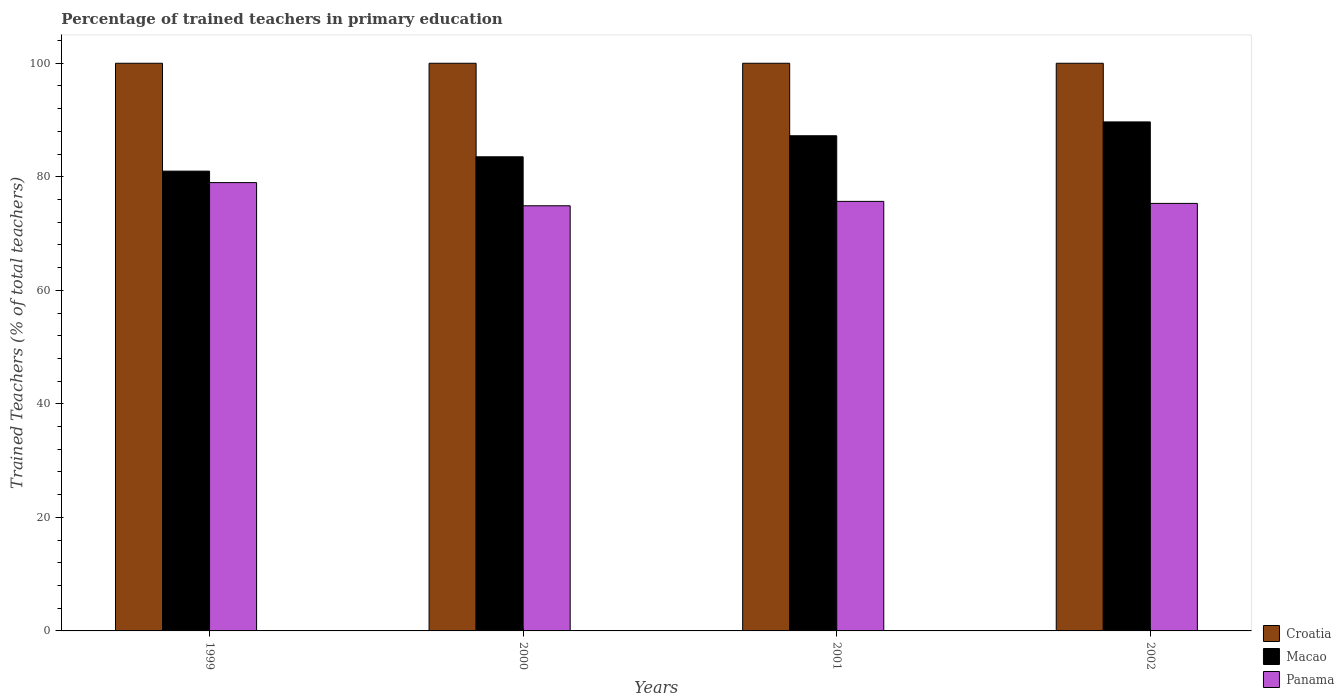How many different coloured bars are there?
Your response must be concise. 3. How many groups of bars are there?
Make the answer very short. 4. How many bars are there on the 1st tick from the left?
Offer a very short reply. 3. How many bars are there on the 4th tick from the right?
Offer a very short reply. 3. What is the label of the 1st group of bars from the left?
Your response must be concise. 1999. What is the percentage of trained teachers in Panama in 2001?
Provide a succinct answer. 75.67. Across all years, what is the maximum percentage of trained teachers in Croatia?
Your response must be concise. 100. Across all years, what is the minimum percentage of trained teachers in Croatia?
Offer a very short reply. 100. In which year was the percentage of trained teachers in Panama maximum?
Give a very brief answer. 1999. In which year was the percentage of trained teachers in Macao minimum?
Offer a terse response. 1999. What is the total percentage of trained teachers in Macao in the graph?
Your answer should be compact. 341.41. What is the difference between the percentage of trained teachers in Panama in 1999 and that in 2000?
Offer a very short reply. 4.08. What is the difference between the percentage of trained teachers in Croatia in 2001 and the percentage of trained teachers in Macao in 2002?
Make the answer very short. 10.33. What is the average percentage of trained teachers in Macao per year?
Your response must be concise. 85.35. In the year 2002, what is the difference between the percentage of trained teachers in Panama and percentage of trained teachers in Macao?
Offer a very short reply. -14.35. Is the percentage of trained teachers in Panama in 1999 less than that in 2001?
Offer a terse response. No. Is the difference between the percentage of trained teachers in Panama in 2001 and 2002 greater than the difference between the percentage of trained teachers in Macao in 2001 and 2002?
Provide a short and direct response. Yes. What is the difference between the highest and the second highest percentage of trained teachers in Macao?
Offer a terse response. 2.44. In how many years, is the percentage of trained teachers in Macao greater than the average percentage of trained teachers in Macao taken over all years?
Offer a terse response. 2. What does the 2nd bar from the left in 2000 represents?
Offer a very short reply. Macao. What does the 1st bar from the right in 2002 represents?
Make the answer very short. Panama. Is it the case that in every year, the sum of the percentage of trained teachers in Croatia and percentage of trained teachers in Panama is greater than the percentage of trained teachers in Macao?
Keep it short and to the point. Yes. How many bars are there?
Keep it short and to the point. 12. How many years are there in the graph?
Offer a terse response. 4. Does the graph contain any zero values?
Offer a very short reply. No. Where does the legend appear in the graph?
Your answer should be compact. Bottom right. What is the title of the graph?
Your answer should be very brief. Percentage of trained teachers in primary education. Does "Northern Mariana Islands" appear as one of the legend labels in the graph?
Provide a short and direct response. No. What is the label or title of the X-axis?
Offer a terse response. Years. What is the label or title of the Y-axis?
Provide a short and direct response. Trained Teachers (% of total teachers). What is the Trained Teachers (% of total teachers) of Croatia in 1999?
Give a very brief answer. 100. What is the Trained Teachers (% of total teachers) in Macao in 1999?
Provide a succinct answer. 81. What is the Trained Teachers (% of total teachers) in Panama in 1999?
Make the answer very short. 78.98. What is the Trained Teachers (% of total teachers) in Macao in 2000?
Make the answer very short. 83.52. What is the Trained Teachers (% of total teachers) in Panama in 2000?
Offer a terse response. 74.89. What is the Trained Teachers (% of total teachers) of Macao in 2001?
Offer a terse response. 87.23. What is the Trained Teachers (% of total teachers) in Panama in 2001?
Your answer should be very brief. 75.67. What is the Trained Teachers (% of total teachers) of Croatia in 2002?
Make the answer very short. 100. What is the Trained Teachers (% of total teachers) in Macao in 2002?
Your answer should be very brief. 89.67. What is the Trained Teachers (% of total teachers) of Panama in 2002?
Your answer should be very brief. 75.31. Across all years, what is the maximum Trained Teachers (% of total teachers) in Macao?
Your answer should be compact. 89.67. Across all years, what is the maximum Trained Teachers (% of total teachers) of Panama?
Give a very brief answer. 78.98. Across all years, what is the minimum Trained Teachers (% of total teachers) of Macao?
Keep it short and to the point. 81. Across all years, what is the minimum Trained Teachers (% of total teachers) of Panama?
Provide a succinct answer. 74.89. What is the total Trained Teachers (% of total teachers) in Croatia in the graph?
Keep it short and to the point. 400. What is the total Trained Teachers (% of total teachers) of Macao in the graph?
Make the answer very short. 341.41. What is the total Trained Teachers (% of total teachers) of Panama in the graph?
Make the answer very short. 304.85. What is the difference between the Trained Teachers (% of total teachers) in Croatia in 1999 and that in 2000?
Provide a short and direct response. 0. What is the difference between the Trained Teachers (% of total teachers) in Macao in 1999 and that in 2000?
Give a very brief answer. -2.53. What is the difference between the Trained Teachers (% of total teachers) of Panama in 1999 and that in 2000?
Make the answer very short. 4.08. What is the difference between the Trained Teachers (% of total teachers) in Croatia in 1999 and that in 2001?
Offer a terse response. 0. What is the difference between the Trained Teachers (% of total teachers) in Macao in 1999 and that in 2001?
Make the answer very short. -6.23. What is the difference between the Trained Teachers (% of total teachers) of Panama in 1999 and that in 2001?
Give a very brief answer. 3.31. What is the difference between the Trained Teachers (% of total teachers) in Macao in 1999 and that in 2002?
Your answer should be compact. -8.67. What is the difference between the Trained Teachers (% of total teachers) in Panama in 1999 and that in 2002?
Offer a terse response. 3.66. What is the difference between the Trained Teachers (% of total teachers) in Croatia in 2000 and that in 2001?
Your answer should be very brief. 0. What is the difference between the Trained Teachers (% of total teachers) of Macao in 2000 and that in 2001?
Make the answer very short. -3.71. What is the difference between the Trained Teachers (% of total teachers) in Panama in 2000 and that in 2001?
Ensure brevity in your answer.  -0.77. What is the difference between the Trained Teachers (% of total teachers) of Croatia in 2000 and that in 2002?
Offer a very short reply. 0. What is the difference between the Trained Teachers (% of total teachers) in Macao in 2000 and that in 2002?
Keep it short and to the point. -6.14. What is the difference between the Trained Teachers (% of total teachers) of Panama in 2000 and that in 2002?
Your answer should be compact. -0.42. What is the difference between the Trained Teachers (% of total teachers) in Macao in 2001 and that in 2002?
Give a very brief answer. -2.44. What is the difference between the Trained Teachers (% of total teachers) in Panama in 2001 and that in 2002?
Offer a terse response. 0.36. What is the difference between the Trained Teachers (% of total teachers) of Croatia in 1999 and the Trained Teachers (% of total teachers) of Macao in 2000?
Give a very brief answer. 16.48. What is the difference between the Trained Teachers (% of total teachers) in Croatia in 1999 and the Trained Teachers (% of total teachers) in Panama in 2000?
Provide a short and direct response. 25.11. What is the difference between the Trained Teachers (% of total teachers) of Macao in 1999 and the Trained Teachers (% of total teachers) of Panama in 2000?
Provide a succinct answer. 6.1. What is the difference between the Trained Teachers (% of total teachers) of Croatia in 1999 and the Trained Teachers (% of total teachers) of Macao in 2001?
Keep it short and to the point. 12.77. What is the difference between the Trained Teachers (% of total teachers) of Croatia in 1999 and the Trained Teachers (% of total teachers) of Panama in 2001?
Your answer should be very brief. 24.33. What is the difference between the Trained Teachers (% of total teachers) in Macao in 1999 and the Trained Teachers (% of total teachers) in Panama in 2001?
Ensure brevity in your answer.  5.33. What is the difference between the Trained Teachers (% of total teachers) of Croatia in 1999 and the Trained Teachers (% of total teachers) of Macao in 2002?
Your answer should be compact. 10.33. What is the difference between the Trained Teachers (% of total teachers) in Croatia in 1999 and the Trained Teachers (% of total teachers) in Panama in 2002?
Ensure brevity in your answer.  24.69. What is the difference between the Trained Teachers (% of total teachers) of Macao in 1999 and the Trained Teachers (% of total teachers) of Panama in 2002?
Provide a succinct answer. 5.68. What is the difference between the Trained Teachers (% of total teachers) in Croatia in 2000 and the Trained Teachers (% of total teachers) in Macao in 2001?
Make the answer very short. 12.77. What is the difference between the Trained Teachers (% of total teachers) of Croatia in 2000 and the Trained Teachers (% of total teachers) of Panama in 2001?
Ensure brevity in your answer.  24.33. What is the difference between the Trained Teachers (% of total teachers) in Macao in 2000 and the Trained Teachers (% of total teachers) in Panama in 2001?
Your response must be concise. 7.86. What is the difference between the Trained Teachers (% of total teachers) of Croatia in 2000 and the Trained Teachers (% of total teachers) of Macao in 2002?
Make the answer very short. 10.33. What is the difference between the Trained Teachers (% of total teachers) of Croatia in 2000 and the Trained Teachers (% of total teachers) of Panama in 2002?
Your response must be concise. 24.69. What is the difference between the Trained Teachers (% of total teachers) of Macao in 2000 and the Trained Teachers (% of total teachers) of Panama in 2002?
Keep it short and to the point. 8.21. What is the difference between the Trained Teachers (% of total teachers) of Croatia in 2001 and the Trained Teachers (% of total teachers) of Macao in 2002?
Your answer should be compact. 10.33. What is the difference between the Trained Teachers (% of total teachers) in Croatia in 2001 and the Trained Teachers (% of total teachers) in Panama in 2002?
Provide a succinct answer. 24.69. What is the difference between the Trained Teachers (% of total teachers) of Macao in 2001 and the Trained Teachers (% of total teachers) of Panama in 2002?
Offer a terse response. 11.92. What is the average Trained Teachers (% of total teachers) of Croatia per year?
Ensure brevity in your answer.  100. What is the average Trained Teachers (% of total teachers) in Macao per year?
Give a very brief answer. 85.35. What is the average Trained Teachers (% of total teachers) in Panama per year?
Make the answer very short. 76.21. In the year 1999, what is the difference between the Trained Teachers (% of total teachers) in Croatia and Trained Teachers (% of total teachers) in Macao?
Offer a very short reply. 19. In the year 1999, what is the difference between the Trained Teachers (% of total teachers) of Croatia and Trained Teachers (% of total teachers) of Panama?
Your response must be concise. 21.02. In the year 1999, what is the difference between the Trained Teachers (% of total teachers) of Macao and Trained Teachers (% of total teachers) of Panama?
Offer a terse response. 2.02. In the year 2000, what is the difference between the Trained Teachers (% of total teachers) in Croatia and Trained Teachers (% of total teachers) in Macao?
Give a very brief answer. 16.48. In the year 2000, what is the difference between the Trained Teachers (% of total teachers) in Croatia and Trained Teachers (% of total teachers) in Panama?
Your answer should be compact. 25.11. In the year 2000, what is the difference between the Trained Teachers (% of total teachers) in Macao and Trained Teachers (% of total teachers) in Panama?
Make the answer very short. 8.63. In the year 2001, what is the difference between the Trained Teachers (% of total teachers) in Croatia and Trained Teachers (% of total teachers) in Macao?
Your answer should be very brief. 12.77. In the year 2001, what is the difference between the Trained Teachers (% of total teachers) of Croatia and Trained Teachers (% of total teachers) of Panama?
Ensure brevity in your answer.  24.33. In the year 2001, what is the difference between the Trained Teachers (% of total teachers) of Macao and Trained Teachers (% of total teachers) of Panama?
Keep it short and to the point. 11.56. In the year 2002, what is the difference between the Trained Teachers (% of total teachers) of Croatia and Trained Teachers (% of total teachers) of Macao?
Your answer should be compact. 10.33. In the year 2002, what is the difference between the Trained Teachers (% of total teachers) of Croatia and Trained Teachers (% of total teachers) of Panama?
Provide a short and direct response. 24.69. In the year 2002, what is the difference between the Trained Teachers (% of total teachers) of Macao and Trained Teachers (% of total teachers) of Panama?
Ensure brevity in your answer.  14.35. What is the ratio of the Trained Teachers (% of total teachers) of Croatia in 1999 to that in 2000?
Offer a very short reply. 1. What is the ratio of the Trained Teachers (% of total teachers) of Macao in 1999 to that in 2000?
Your response must be concise. 0.97. What is the ratio of the Trained Teachers (% of total teachers) of Panama in 1999 to that in 2000?
Ensure brevity in your answer.  1.05. What is the ratio of the Trained Teachers (% of total teachers) of Croatia in 1999 to that in 2001?
Make the answer very short. 1. What is the ratio of the Trained Teachers (% of total teachers) of Panama in 1999 to that in 2001?
Offer a very short reply. 1.04. What is the ratio of the Trained Teachers (% of total teachers) in Croatia in 1999 to that in 2002?
Make the answer very short. 1. What is the ratio of the Trained Teachers (% of total teachers) in Macao in 1999 to that in 2002?
Keep it short and to the point. 0.9. What is the ratio of the Trained Teachers (% of total teachers) of Panama in 1999 to that in 2002?
Make the answer very short. 1.05. What is the ratio of the Trained Teachers (% of total teachers) of Macao in 2000 to that in 2001?
Make the answer very short. 0.96. What is the ratio of the Trained Teachers (% of total teachers) of Croatia in 2000 to that in 2002?
Your answer should be very brief. 1. What is the ratio of the Trained Teachers (% of total teachers) of Macao in 2000 to that in 2002?
Make the answer very short. 0.93. What is the ratio of the Trained Teachers (% of total teachers) of Croatia in 2001 to that in 2002?
Offer a terse response. 1. What is the ratio of the Trained Teachers (% of total teachers) of Macao in 2001 to that in 2002?
Give a very brief answer. 0.97. What is the ratio of the Trained Teachers (% of total teachers) in Panama in 2001 to that in 2002?
Provide a succinct answer. 1. What is the difference between the highest and the second highest Trained Teachers (% of total teachers) in Macao?
Offer a very short reply. 2.44. What is the difference between the highest and the second highest Trained Teachers (% of total teachers) in Panama?
Keep it short and to the point. 3.31. What is the difference between the highest and the lowest Trained Teachers (% of total teachers) of Croatia?
Your response must be concise. 0. What is the difference between the highest and the lowest Trained Teachers (% of total teachers) of Macao?
Your response must be concise. 8.67. What is the difference between the highest and the lowest Trained Teachers (% of total teachers) in Panama?
Offer a terse response. 4.08. 